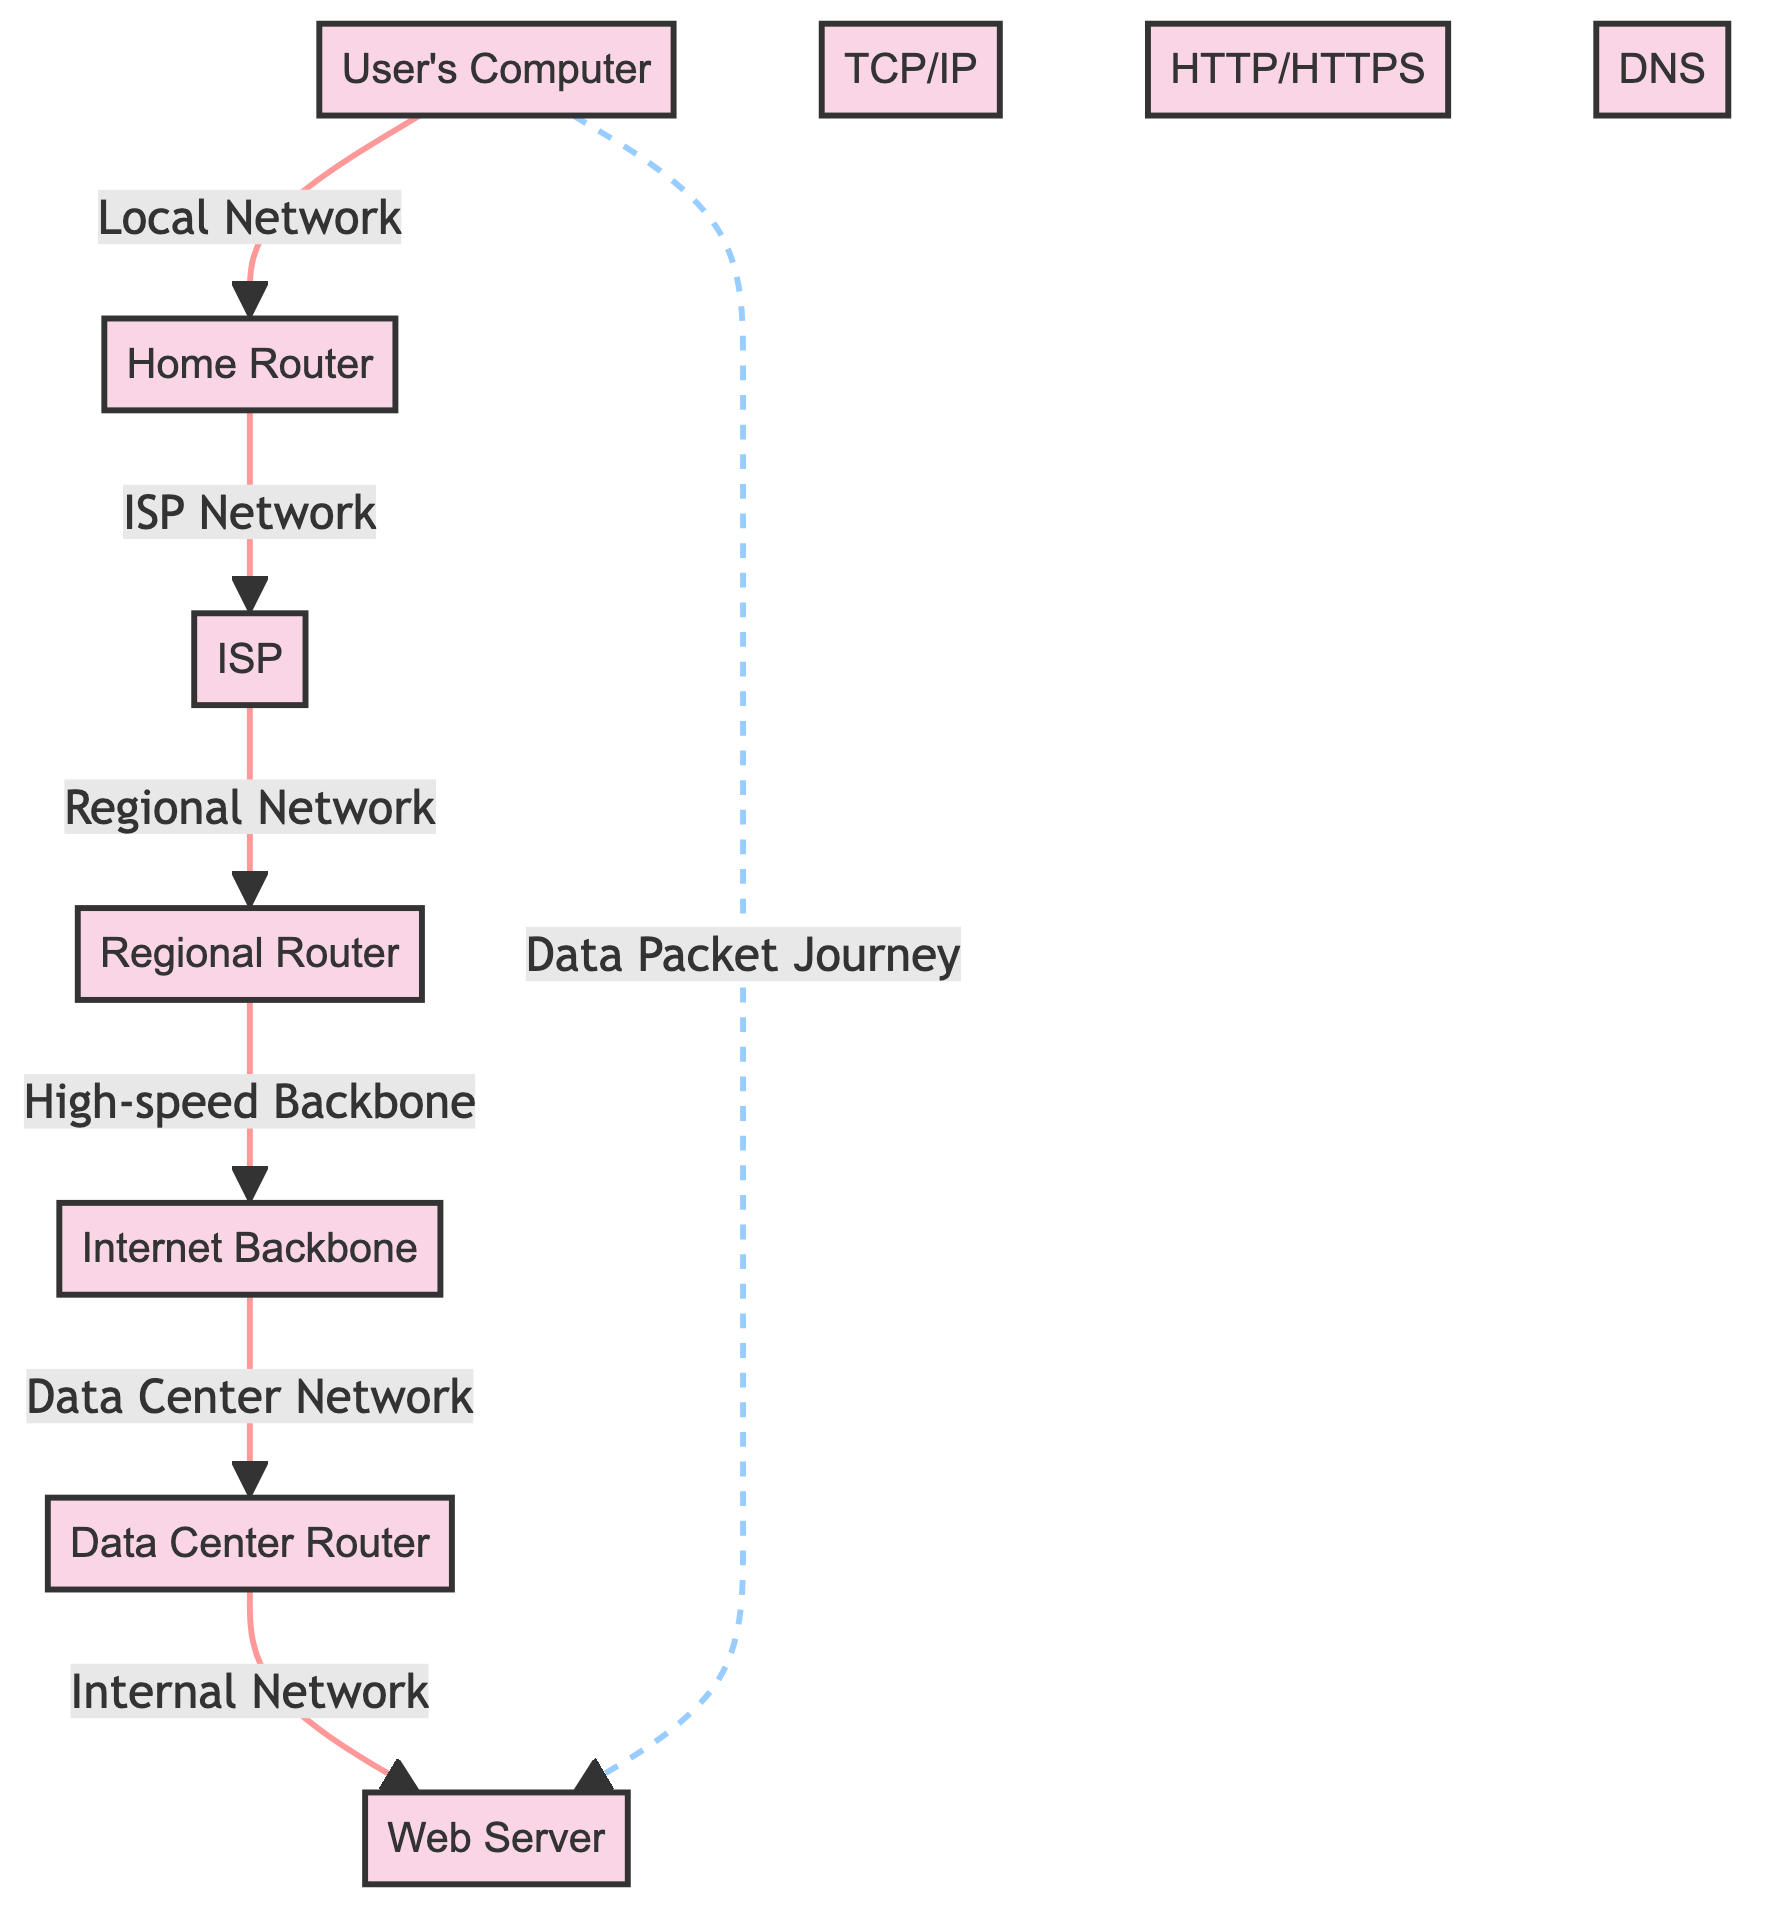What is the starting point of the data packet journey? The diagram shows that the data packet journey starts at the "User's Computer", which is the first node in the flowchart.
Answer: User's Computer How many nodes are present in the diagram? By counting all distinct points in the flowchart, including the user's computer, router, ISP, regional router, backbone, data center router, and web server, we find there are 7 nodes total.
Answer: 7 What role does the "Home Router" serve in the journey? According to the diagram, the "Home Router" connects the "User's Computer" to the "ISP", taking data from the user's local network and passing it on to the internet.
Answer: Connects User's Computer to ISP Which protocol is responsible for translating domain names into IP addresses? The diagram lists "DNS" as one of the nodes, indicating its function in the process of converting domain names into their corresponding IP addresses.
Answer: DNS What is the last node before the web server in the data packet journey? The diagram indicates that the "Data Center Router" is the last node that the data packet encounters before reaching the final node, which is the web server.
Answer: Data Center Router What type of data flow is represented between the user's computer and the web server? The dashed line labeled "Data Packet Journey" indicates a non-linear connection or an overview of the overall flow from the user's computer to the web server.
Answer: Data Packet Journey Which protocol is shown as operating during the data transmission? The diagram features "TCP/IP" as a critical protocol involved in the data transmission process from the user’s end to the web server.
Answer: TCP/IP What is the highest level of connectivity in the diagram? The "Internet Backbone" is indicated as part of the flowchart and is noted as the high-speed backbone of the internet, signifying the broadest and fastest level of connectivity.
Answer: Internet Backbone What kind of network does the "ISP" represent? The diagram categorizes the "ISP" under the "ISP Network," which indicates that it functions as an intermediary provider connecting users to the internet.
Answer: ISP Network 